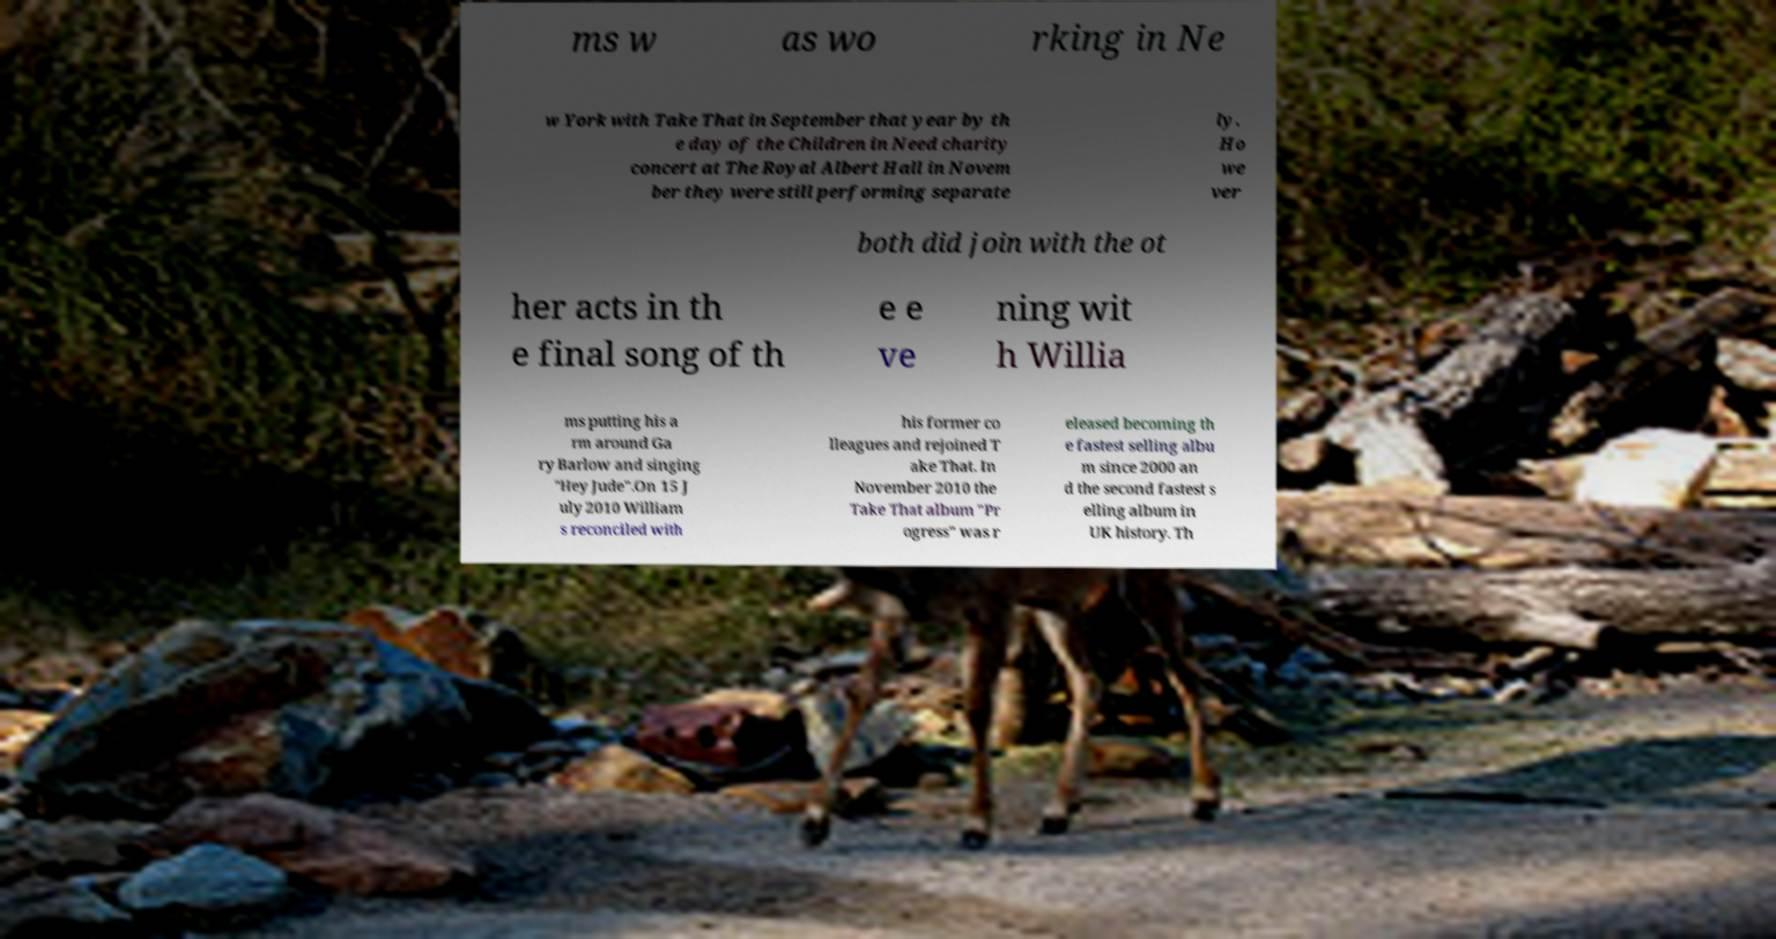Can you read and provide the text displayed in the image?This photo seems to have some interesting text. Can you extract and type it out for me? ms w as wo rking in Ne w York with Take That in September that year by th e day of the Children in Need charity concert at The Royal Albert Hall in Novem ber they were still performing separate ly. Ho we ver both did join with the ot her acts in th e final song of th e e ve ning wit h Willia ms putting his a rm around Ga ry Barlow and singing "Hey Jude".On 15 J uly 2010 William s reconciled with his former co lleagues and rejoined T ake That. In November 2010 the Take That album "Pr ogress" was r eleased becoming th e fastest selling albu m since 2000 an d the second fastest s elling album in UK history. Th 